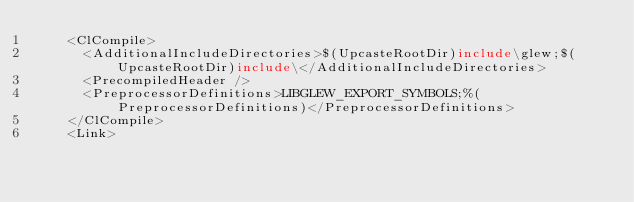<code> <loc_0><loc_0><loc_500><loc_500><_XML_>    <ClCompile>
      <AdditionalIncludeDirectories>$(UpcasteRootDir)include\glew;$(UpcasteRootDir)include\</AdditionalIncludeDirectories>
      <PrecompiledHeader />
      <PreprocessorDefinitions>LIBGLEW_EXPORT_SYMBOLS;%(PreprocessorDefinitions)</PreprocessorDefinitions>
    </ClCompile>
    <Link></code> 